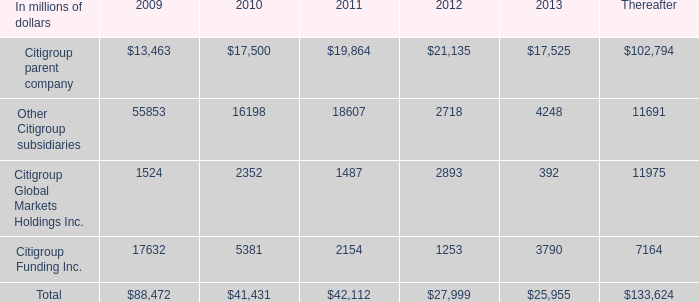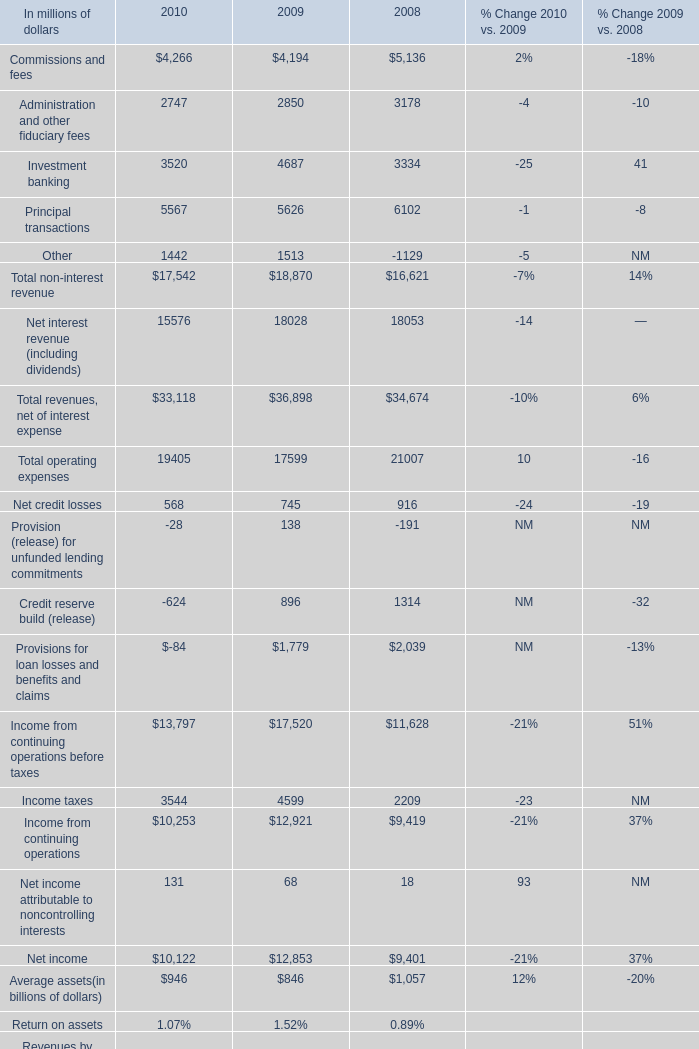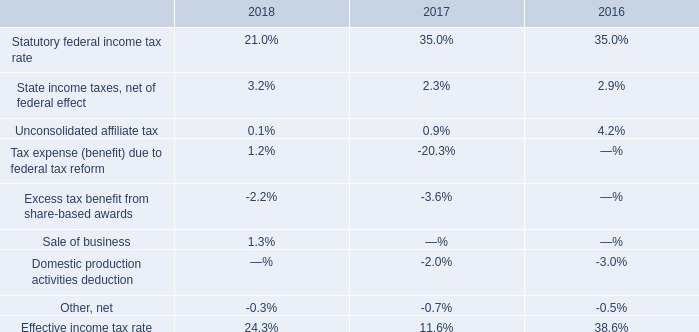What is the total amount of Administration and other fiduciary fees of 2009, and Citigroup parent company of Thereafter ? 
Computations: (2850.0 + 102794.0)
Answer: 105644.0. 